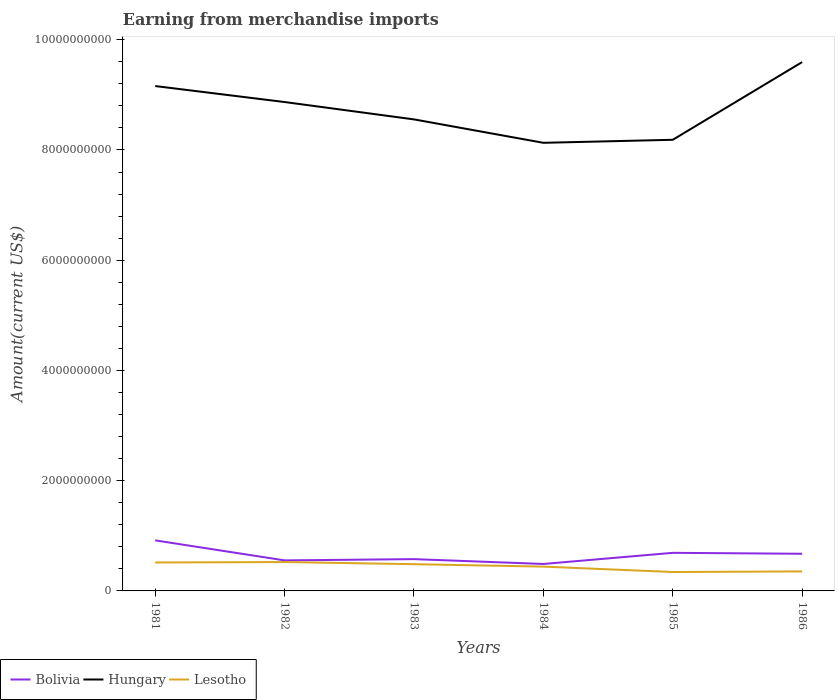How many different coloured lines are there?
Give a very brief answer. 3. Is the number of lines equal to the number of legend labels?
Give a very brief answer. Yes. Across all years, what is the maximum amount earned from merchandise imports in Lesotho?
Your answer should be very brief. 3.43e+08. What is the total amount earned from merchandise imports in Bolivia in the graph?
Your response must be concise. 2.43e+08. What is the difference between the highest and the second highest amount earned from merchandise imports in Lesotho?
Your answer should be very brief. 1.81e+08. What is the difference between the highest and the lowest amount earned from merchandise imports in Lesotho?
Provide a short and direct response. 3. Is the amount earned from merchandise imports in Hungary strictly greater than the amount earned from merchandise imports in Lesotho over the years?
Make the answer very short. No. How many lines are there?
Your answer should be very brief. 3. Does the graph contain any zero values?
Provide a short and direct response. No. Does the graph contain grids?
Offer a terse response. No. Where does the legend appear in the graph?
Ensure brevity in your answer.  Bottom left. How many legend labels are there?
Offer a very short reply. 3. How are the legend labels stacked?
Your answer should be very brief. Horizontal. What is the title of the graph?
Provide a short and direct response. Earning from merchandise imports. What is the label or title of the Y-axis?
Keep it short and to the point. Amount(current US$). What is the Amount(current US$) of Bolivia in 1981?
Your answer should be compact. 9.17e+08. What is the Amount(current US$) in Hungary in 1981?
Offer a very short reply. 9.16e+09. What is the Amount(current US$) in Lesotho in 1981?
Your answer should be very brief. 5.16e+08. What is the Amount(current US$) in Bolivia in 1982?
Keep it short and to the point. 5.54e+08. What is the Amount(current US$) of Hungary in 1982?
Your answer should be very brief. 8.87e+09. What is the Amount(current US$) in Lesotho in 1982?
Your answer should be compact. 5.24e+08. What is the Amount(current US$) in Bolivia in 1983?
Your answer should be very brief. 5.77e+08. What is the Amount(current US$) of Hungary in 1983?
Your response must be concise. 8.56e+09. What is the Amount(current US$) of Lesotho in 1983?
Make the answer very short. 4.85e+08. What is the Amount(current US$) of Bolivia in 1984?
Provide a short and direct response. 4.89e+08. What is the Amount(current US$) of Hungary in 1984?
Keep it short and to the point. 8.13e+09. What is the Amount(current US$) of Lesotho in 1984?
Your response must be concise. 4.41e+08. What is the Amount(current US$) of Bolivia in 1985?
Your answer should be very brief. 6.91e+08. What is the Amount(current US$) of Hungary in 1985?
Offer a terse response. 8.18e+09. What is the Amount(current US$) of Lesotho in 1985?
Your answer should be compact. 3.43e+08. What is the Amount(current US$) in Bolivia in 1986?
Offer a terse response. 6.74e+08. What is the Amount(current US$) in Hungary in 1986?
Make the answer very short. 9.60e+09. What is the Amount(current US$) of Lesotho in 1986?
Ensure brevity in your answer.  3.54e+08. Across all years, what is the maximum Amount(current US$) of Bolivia?
Provide a short and direct response. 9.17e+08. Across all years, what is the maximum Amount(current US$) in Hungary?
Provide a succinct answer. 9.60e+09. Across all years, what is the maximum Amount(current US$) in Lesotho?
Your answer should be compact. 5.24e+08. Across all years, what is the minimum Amount(current US$) of Bolivia?
Provide a short and direct response. 4.89e+08. Across all years, what is the minimum Amount(current US$) in Hungary?
Make the answer very short. 8.13e+09. Across all years, what is the minimum Amount(current US$) in Lesotho?
Provide a short and direct response. 3.43e+08. What is the total Amount(current US$) of Bolivia in the graph?
Provide a short and direct response. 3.90e+09. What is the total Amount(current US$) in Hungary in the graph?
Make the answer very short. 5.25e+1. What is the total Amount(current US$) in Lesotho in the graph?
Ensure brevity in your answer.  2.66e+09. What is the difference between the Amount(current US$) in Bolivia in 1981 and that in 1982?
Make the answer very short. 3.63e+08. What is the difference between the Amount(current US$) in Hungary in 1981 and that in 1982?
Provide a short and direct response. 2.90e+08. What is the difference between the Amount(current US$) in Lesotho in 1981 and that in 1982?
Ensure brevity in your answer.  -8.00e+06. What is the difference between the Amount(current US$) in Bolivia in 1981 and that in 1983?
Your answer should be very brief. 3.40e+08. What is the difference between the Amount(current US$) in Hungary in 1981 and that in 1983?
Your answer should be compact. 6.05e+08. What is the difference between the Amount(current US$) in Lesotho in 1981 and that in 1983?
Provide a succinct answer. 3.10e+07. What is the difference between the Amount(current US$) of Bolivia in 1981 and that in 1984?
Offer a very short reply. 4.28e+08. What is the difference between the Amount(current US$) in Hungary in 1981 and that in 1984?
Your response must be concise. 1.03e+09. What is the difference between the Amount(current US$) in Lesotho in 1981 and that in 1984?
Give a very brief answer. 7.50e+07. What is the difference between the Amount(current US$) of Bolivia in 1981 and that in 1985?
Provide a succinct answer. 2.26e+08. What is the difference between the Amount(current US$) in Hungary in 1981 and that in 1985?
Provide a short and direct response. 9.75e+08. What is the difference between the Amount(current US$) of Lesotho in 1981 and that in 1985?
Your answer should be compact. 1.73e+08. What is the difference between the Amount(current US$) in Bolivia in 1981 and that in 1986?
Offer a terse response. 2.43e+08. What is the difference between the Amount(current US$) in Hungary in 1981 and that in 1986?
Keep it short and to the point. -4.35e+08. What is the difference between the Amount(current US$) of Lesotho in 1981 and that in 1986?
Give a very brief answer. 1.62e+08. What is the difference between the Amount(current US$) in Bolivia in 1982 and that in 1983?
Provide a succinct answer. -2.30e+07. What is the difference between the Amount(current US$) in Hungary in 1982 and that in 1983?
Your answer should be compact. 3.15e+08. What is the difference between the Amount(current US$) of Lesotho in 1982 and that in 1983?
Keep it short and to the point. 3.90e+07. What is the difference between the Amount(current US$) of Bolivia in 1982 and that in 1984?
Ensure brevity in your answer.  6.50e+07. What is the difference between the Amount(current US$) in Hungary in 1982 and that in 1984?
Make the answer very short. 7.40e+08. What is the difference between the Amount(current US$) in Lesotho in 1982 and that in 1984?
Ensure brevity in your answer.  8.30e+07. What is the difference between the Amount(current US$) of Bolivia in 1982 and that in 1985?
Provide a short and direct response. -1.37e+08. What is the difference between the Amount(current US$) in Hungary in 1982 and that in 1985?
Give a very brief answer. 6.85e+08. What is the difference between the Amount(current US$) of Lesotho in 1982 and that in 1985?
Your answer should be very brief. 1.81e+08. What is the difference between the Amount(current US$) in Bolivia in 1982 and that in 1986?
Your answer should be very brief. -1.20e+08. What is the difference between the Amount(current US$) in Hungary in 1982 and that in 1986?
Keep it short and to the point. -7.25e+08. What is the difference between the Amount(current US$) of Lesotho in 1982 and that in 1986?
Your answer should be very brief. 1.70e+08. What is the difference between the Amount(current US$) in Bolivia in 1983 and that in 1984?
Your answer should be very brief. 8.80e+07. What is the difference between the Amount(current US$) in Hungary in 1983 and that in 1984?
Provide a succinct answer. 4.25e+08. What is the difference between the Amount(current US$) of Lesotho in 1983 and that in 1984?
Offer a terse response. 4.40e+07. What is the difference between the Amount(current US$) in Bolivia in 1983 and that in 1985?
Give a very brief answer. -1.14e+08. What is the difference between the Amount(current US$) in Hungary in 1983 and that in 1985?
Your answer should be compact. 3.70e+08. What is the difference between the Amount(current US$) in Lesotho in 1983 and that in 1985?
Provide a short and direct response. 1.42e+08. What is the difference between the Amount(current US$) of Bolivia in 1983 and that in 1986?
Keep it short and to the point. -9.70e+07. What is the difference between the Amount(current US$) in Hungary in 1983 and that in 1986?
Keep it short and to the point. -1.04e+09. What is the difference between the Amount(current US$) of Lesotho in 1983 and that in 1986?
Give a very brief answer. 1.31e+08. What is the difference between the Amount(current US$) of Bolivia in 1984 and that in 1985?
Provide a succinct answer. -2.02e+08. What is the difference between the Amount(current US$) of Hungary in 1984 and that in 1985?
Provide a short and direct response. -5.50e+07. What is the difference between the Amount(current US$) in Lesotho in 1984 and that in 1985?
Provide a succinct answer. 9.80e+07. What is the difference between the Amount(current US$) in Bolivia in 1984 and that in 1986?
Your answer should be very brief. -1.85e+08. What is the difference between the Amount(current US$) of Hungary in 1984 and that in 1986?
Ensure brevity in your answer.  -1.46e+09. What is the difference between the Amount(current US$) in Lesotho in 1984 and that in 1986?
Provide a succinct answer. 8.70e+07. What is the difference between the Amount(current US$) in Bolivia in 1985 and that in 1986?
Provide a short and direct response. 1.70e+07. What is the difference between the Amount(current US$) of Hungary in 1985 and that in 1986?
Your answer should be compact. -1.41e+09. What is the difference between the Amount(current US$) in Lesotho in 1985 and that in 1986?
Provide a succinct answer. -1.10e+07. What is the difference between the Amount(current US$) of Bolivia in 1981 and the Amount(current US$) of Hungary in 1982?
Make the answer very short. -7.95e+09. What is the difference between the Amount(current US$) in Bolivia in 1981 and the Amount(current US$) in Lesotho in 1982?
Your answer should be compact. 3.93e+08. What is the difference between the Amount(current US$) of Hungary in 1981 and the Amount(current US$) of Lesotho in 1982?
Offer a terse response. 8.64e+09. What is the difference between the Amount(current US$) of Bolivia in 1981 and the Amount(current US$) of Hungary in 1983?
Your answer should be very brief. -7.64e+09. What is the difference between the Amount(current US$) in Bolivia in 1981 and the Amount(current US$) in Lesotho in 1983?
Your answer should be compact. 4.32e+08. What is the difference between the Amount(current US$) of Hungary in 1981 and the Amount(current US$) of Lesotho in 1983?
Offer a very short reply. 8.68e+09. What is the difference between the Amount(current US$) in Bolivia in 1981 and the Amount(current US$) in Hungary in 1984?
Offer a terse response. -7.21e+09. What is the difference between the Amount(current US$) of Bolivia in 1981 and the Amount(current US$) of Lesotho in 1984?
Your answer should be very brief. 4.76e+08. What is the difference between the Amount(current US$) in Hungary in 1981 and the Amount(current US$) in Lesotho in 1984?
Your answer should be very brief. 8.72e+09. What is the difference between the Amount(current US$) of Bolivia in 1981 and the Amount(current US$) of Hungary in 1985?
Make the answer very short. -7.27e+09. What is the difference between the Amount(current US$) of Bolivia in 1981 and the Amount(current US$) of Lesotho in 1985?
Provide a succinct answer. 5.74e+08. What is the difference between the Amount(current US$) in Hungary in 1981 and the Amount(current US$) in Lesotho in 1985?
Provide a succinct answer. 8.82e+09. What is the difference between the Amount(current US$) in Bolivia in 1981 and the Amount(current US$) in Hungary in 1986?
Your answer should be compact. -8.68e+09. What is the difference between the Amount(current US$) of Bolivia in 1981 and the Amount(current US$) of Lesotho in 1986?
Offer a very short reply. 5.63e+08. What is the difference between the Amount(current US$) in Hungary in 1981 and the Amount(current US$) in Lesotho in 1986?
Your response must be concise. 8.81e+09. What is the difference between the Amount(current US$) of Bolivia in 1982 and the Amount(current US$) of Hungary in 1983?
Your answer should be very brief. -8.00e+09. What is the difference between the Amount(current US$) of Bolivia in 1982 and the Amount(current US$) of Lesotho in 1983?
Your response must be concise. 6.90e+07. What is the difference between the Amount(current US$) of Hungary in 1982 and the Amount(current US$) of Lesotho in 1983?
Give a very brief answer. 8.38e+09. What is the difference between the Amount(current US$) in Bolivia in 1982 and the Amount(current US$) in Hungary in 1984?
Keep it short and to the point. -7.58e+09. What is the difference between the Amount(current US$) of Bolivia in 1982 and the Amount(current US$) of Lesotho in 1984?
Offer a terse response. 1.13e+08. What is the difference between the Amount(current US$) of Hungary in 1982 and the Amount(current US$) of Lesotho in 1984?
Make the answer very short. 8.43e+09. What is the difference between the Amount(current US$) in Bolivia in 1982 and the Amount(current US$) in Hungary in 1985?
Provide a succinct answer. -7.63e+09. What is the difference between the Amount(current US$) in Bolivia in 1982 and the Amount(current US$) in Lesotho in 1985?
Provide a succinct answer. 2.11e+08. What is the difference between the Amount(current US$) of Hungary in 1982 and the Amount(current US$) of Lesotho in 1985?
Provide a succinct answer. 8.53e+09. What is the difference between the Amount(current US$) in Bolivia in 1982 and the Amount(current US$) in Hungary in 1986?
Make the answer very short. -9.04e+09. What is the difference between the Amount(current US$) in Bolivia in 1982 and the Amount(current US$) in Lesotho in 1986?
Provide a succinct answer. 2.00e+08. What is the difference between the Amount(current US$) in Hungary in 1982 and the Amount(current US$) in Lesotho in 1986?
Your response must be concise. 8.52e+09. What is the difference between the Amount(current US$) of Bolivia in 1983 and the Amount(current US$) of Hungary in 1984?
Provide a short and direct response. -7.55e+09. What is the difference between the Amount(current US$) in Bolivia in 1983 and the Amount(current US$) in Lesotho in 1984?
Offer a very short reply. 1.36e+08. What is the difference between the Amount(current US$) in Hungary in 1983 and the Amount(current US$) in Lesotho in 1984?
Your answer should be very brief. 8.11e+09. What is the difference between the Amount(current US$) in Bolivia in 1983 and the Amount(current US$) in Hungary in 1985?
Ensure brevity in your answer.  -7.61e+09. What is the difference between the Amount(current US$) of Bolivia in 1983 and the Amount(current US$) of Lesotho in 1985?
Provide a short and direct response. 2.34e+08. What is the difference between the Amount(current US$) of Hungary in 1983 and the Amount(current US$) of Lesotho in 1985?
Keep it short and to the point. 8.21e+09. What is the difference between the Amount(current US$) in Bolivia in 1983 and the Amount(current US$) in Hungary in 1986?
Your answer should be compact. -9.02e+09. What is the difference between the Amount(current US$) of Bolivia in 1983 and the Amount(current US$) of Lesotho in 1986?
Provide a short and direct response. 2.23e+08. What is the difference between the Amount(current US$) of Hungary in 1983 and the Amount(current US$) of Lesotho in 1986?
Provide a short and direct response. 8.20e+09. What is the difference between the Amount(current US$) of Bolivia in 1984 and the Amount(current US$) of Hungary in 1985?
Give a very brief answer. -7.70e+09. What is the difference between the Amount(current US$) of Bolivia in 1984 and the Amount(current US$) of Lesotho in 1985?
Offer a very short reply. 1.46e+08. What is the difference between the Amount(current US$) of Hungary in 1984 and the Amount(current US$) of Lesotho in 1985?
Your answer should be compact. 7.79e+09. What is the difference between the Amount(current US$) in Bolivia in 1984 and the Amount(current US$) in Hungary in 1986?
Provide a short and direct response. -9.11e+09. What is the difference between the Amount(current US$) of Bolivia in 1984 and the Amount(current US$) of Lesotho in 1986?
Provide a succinct answer. 1.35e+08. What is the difference between the Amount(current US$) of Hungary in 1984 and the Amount(current US$) of Lesotho in 1986?
Offer a very short reply. 7.78e+09. What is the difference between the Amount(current US$) of Bolivia in 1985 and the Amount(current US$) of Hungary in 1986?
Offer a terse response. -8.90e+09. What is the difference between the Amount(current US$) in Bolivia in 1985 and the Amount(current US$) in Lesotho in 1986?
Your answer should be very brief. 3.37e+08. What is the difference between the Amount(current US$) in Hungary in 1985 and the Amount(current US$) in Lesotho in 1986?
Provide a succinct answer. 7.83e+09. What is the average Amount(current US$) in Bolivia per year?
Give a very brief answer. 6.50e+08. What is the average Amount(current US$) in Hungary per year?
Your answer should be compact. 8.75e+09. What is the average Amount(current US$) of Lesotho per year?
Offer a very short reply. 4.44e+08. In the year 1981, what is the difference between the Amount(current US$) in Bolivia and Amount(current US$) in Hungary?
Offer a terse response. -8.24e+09. In the year 1981, what is the difference between the Amount(current US$) in Bolivia and Amount(current US$) in Lesotho?
Offer a terse response. 4.01e+08. In the year 1981, what is the difference between the Amount(current US$) in Hungary and Amount(current US$) in Lesotho?
Keep it short and to the point. 8.64e+09. In the year 1982, what is the difference between the Amount(current US$) in Bolivia and Amount(current US$) in Hungary?
Keep it short and to the point. -8.32e+09. In the year 1982, what is the difference between the Amount(current US$) in Bolivia and Amount(current US$) in Lesotho?
Give a very brief answer. 3.00e+07. In the year 1982, what is the difference between the Amount(current US$) in Hungary and Amount(current US$) in Lesotho?
Your answer should be compact. 8.35e+09. In the year 1983, what is the difference between the Amount(current US$) in Bolivia and Amount(current US$) in Hungary?
Keep it short and to the point. -7.98e+09. In the year 1983, what is the difference between the Amount(current US$) of Bolivia and Amount(current US$) of Lesotho?
Your response must be concise. 9.20e+07. In the year 1983, what is the difference between the Amount(current US$) of Hungary and Amount(current US$) of Lesotho?
Provide a short and direct response. 8.07e+09. In the year 1984, what is the difference between the Amount(current US$) in Bolivia and Amount(current US$) in Hungary?
Offer a terse response. -7.64e+09. In the year 1984, what is the difference between the Amount(current US$) in Bolivia and Amount(current US$) in Lesotho?
Give a very brief answer. 4.80e+07. In the year 1984, what is the difference between the Amount(current US$) in Hungary and Amount(current US$) in Lesotho?
Your answer should be compact. 7.69e+09. In the year 1985, what is the difference between the Amount(current US$) of Bolivia and Amount(current US$) of Hungary?
Your answer should be very brief. -7.49e+09. In the year 1985, what is the difference between the Amount(current US$) in Bolivia and Amount(current US$) in Lesotho?
Ensure brevity in your answer.  3.48e+08. In the year 1985, what is the difference between the Amount(current US$) of Hungary and Amount(current US$) of Lesotho?
Offer a terse response. 7.84e+09. In the year 1986, what is the difference between the Amount(current US$) of Bolivia and Amount(current US$) of Hungary?
Offer a very short reply. -8.92e+09. In the year 1986, what is the difference between the Amount(current US$) of Bolivia and Amount(current US$) of Lesotho?
Provide a short and direct response. 3.20e+08. In the year 1986, what is the difference between the Amount(current US$) of Hungary and Amount(current US$) of Lesotho?
Make the answer very short. 9.24e+09. What is the ratio of the Amount(current US$) in Bolivia in 1981 to that in 1982?
Make the answer very short. 1.66. What is the ratio of the Amount(current US$) of Hungary in 1981 to that in 1982?
Provide a short and direct response. 1.03. What is the ratio of the Amount(current US$) in Lesotho in 1981 to that in 1982?
Offer a very short reply. 0.98. What is the ratio of the Amount(current US$) in Bolivia in 1981 to that in 1983?
Your answer should be very brief. 1.59. What is the ratio of the Amount(current US$) of Hungary in 1981 to that in 1983?
Your answer should be very brief. 1.07. What is the ratio of the Amount(current US$) in Lesotho in 1981 to that in 1983?
Give a very brief answer. 1.06. What is the ratio of the Amount(current US$) of Bolivia in 1981 to that in 1984?
Offer a very short reply. 1.88. What is the ratio of the Amount(current US$) in Hungary in 1981 to that in 1984?
Provide a short and direct response. 1.13. What is the ratio of the Amount(current US$) in Lesotho in 1981 to that in 1984?
Offer a terse response. 1.17. What is the ratio of the Amount(current US$) in Bolivia in 1981 to that in 1985?
Make the answer very short. 1.33. What is the ratio of the Amount(current US$) in Hungary in 1981 to that in 1985?
Ensure brevity in your answer.  1.12. What is the ratio of the Amount(current US$) in Lesotho in 1981 to that in 1985?
Make the answer very short. 1.5. What is the ratio of the Amount(current US$) of Bolivia in 1981 to that in 1986?
Give a very brief answer. 1.36. What is the ratio of the Amount(current US$) in Hungary in 1981 to that in 1986?
Ensure brevity in your answer.  0.95. What is the ratio of the Amount(current US$) of Lesotho in 1981 to that in 1986?
Your response must be concise. 1.46. What is the ratio of the Amount(current US$) of Bolivia in 1982 to that in 1983?
Your response must be concise. 0.96. What is the ratio of the Amount(current US$) in Hungary in 1982 to that in 1983?
Offer a very short reply. 1.04. What is the ratio of the Amount(current US$) of Lesotho in 1982 to that in 1983?
Ensure brevity in your answer.  1.08. What is the ratio of the Amount(current US$) in Bolivia in 1982 to that in 1984?
Offer a terse response. 1.13. What is the ratio of the Amount(current US$) of Hungary in 1982 to that in 1984?
Ensure brevity in your answer.  1.09. What is the ratio of the Amount(current US$) in Lesotho in 1982 to that in 1984?
Provide a succinct answer. 1.19. What is the ratio of the Amount(current US$) of Bolivia in 1982 to that in 1985?
Your response must be concise. 0.8. What is the ratio of the Amount(current US$) in Hungary in 1982 to that in 1985?
Your response must be concise. 1.08. What is the ratio of the Amount(current US$) in Lesotho in 1982 to that in 1985?
Your answer should be compact. 1.53. What is the ratio of the Amount(current US$) in Bolivia in 1982 to that in 1986?
Keep it short and to the point. 0.82. What is the ratio of the Amount(current US$) in Hungary in 1982 to that in 1986?
Offer a terse response. 0.92. What is the ratio of the Amount(current US$) of Lesotho in 1982 to that in 1986?
Your answer should be compact. 1.48. What is the ratio of the Amount(current US$) in Bolivia in 1983 to that in 1984?
Your answer should be compact. 1.18. What is the ratio of the Amount(current US$) of Hungary in 1983 to that in 1984?
Give a very brief answer. 1.05. What is the ratio of the Amount(current US$) in Lesotho in 1983 to that in 1984?
Keep it short and to the point. 1.1. What is the ratio of the Amount(current US$) in Bolivia in 1983 to that in 1985?
Make the answer very short. 0.83. What is the ratio of the Amount(current US$) in Hungary in 1983 to that in 1985?
Your answer should be very brief. 1.05. What is the ratio of the Amount(current US$) of Lesotho in 1983 to that in 1985?
Your answer should be compact. 1.41. What is the ratio of the Amount(current US$) of Bolivia in 1983 to that in 1986?
Offer a terse response. 0.86. What is the ratio of the Amount(current US$) of Hungary in 1983 to that in 1986?
Offer a terse response. 0.89. What is the ratio of the Amount(current US$) of Lesotho in 1983 to that in 1986?
Keep it short and to the point. 1.37. What is the ratio of the Amount(current US$) in Bolivia in 1984 to that in 1985?
Give a very brief answer. 0.71. What is the ratio of the Amount(current US$) in Lesotho in 1984 to that in 1985?
Your response must be concise. 1.29. What is the ratio of the Amount(current US$) of Bolivia in 1984 to that in 1986?
Provide a succinct answer. 0.73. What is the ratio of the Amount(current US$) in Hungary in 1984 to that in 1986?
Offer a terse response. 0.85. What is the ratio of the Amount(current US$) in Lesotho in 1984 to that in 1986?
Provide a succinct answer. 1.25. What is the ratio of the Amount(current US$) of Bolivia in 1985 to that in 1986?
Provide a succinct answer. 1.03. What is the ratio of the Amount(current US$) of Hungary in 1985 to that in 1986?
Give a very brief answer. 0.85. What is the ratio of the Amount(current US$) of Lesotho in 1985 to that in 1986?
Provide a short and direct response. 0.97. What is the difference between the highest and the second highest Amount(current US$) in Bolivia?
Give a very brief answer. 2.26e+08. What is the difference between the highest and the second highest Amount(current US$) in Hungary?
Your answer should be very brief. 4.35e+08. What is the difference between the highest and the second highest Amount(current US$) of Lesotho?
Ensure brevity in your answer.  8.00e+06. What is the difference between the highest and the lowest Amount(current US$) of Bolivia?
Your response must be concise. 4.28e+08. What is the difference between the highest and the lowest Amount(current US$) of Hungary?
Give a very brief answer. 1.46e+09. What is the difference between the highest and the lowest Amount(current US$) of Lesotho?
Provide a short and direct response. 1.81e+08. 